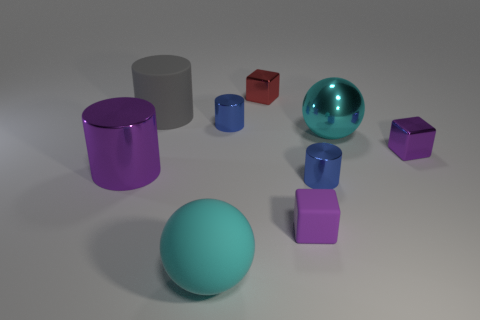How many small cubes are made of the same material as the purple cylinder?
Your answer should be very brief. 2. What material is the large thing that is to the right of the large rubber sphere left of the cyan thing right of the purple matte thing made of?
Offer a terse response. Metal. There is a small metallic object that is behind the gray matte cylinder left of the red block; what is its color?
Make the answer very short. Red. What is the color of the ball that is the same size as the cyan rubber thing?
Make the answer very short. Cyan. How many small objects are either gray objects or blue objects?
Keep it short and to the point. 2. Is the number of cyan balls on the left side of the large purple object greater than the number of small objects that are right of the tiny red thing?
Provide a short and direct response. No. There is a thing that is the same color as the metallic ball; what size is it?
Provide a short and direct response. Large. How many other things are there of the same size as the red shiny thing?
Your answer should be compact. 4. Is the big cylinder that is right of the big purple thing made of the same material as the small red block?
Ensure brevity in your answer.  No. How many other objects are the same color as the tiny matte block?
Keep it short and to the point. 2. 